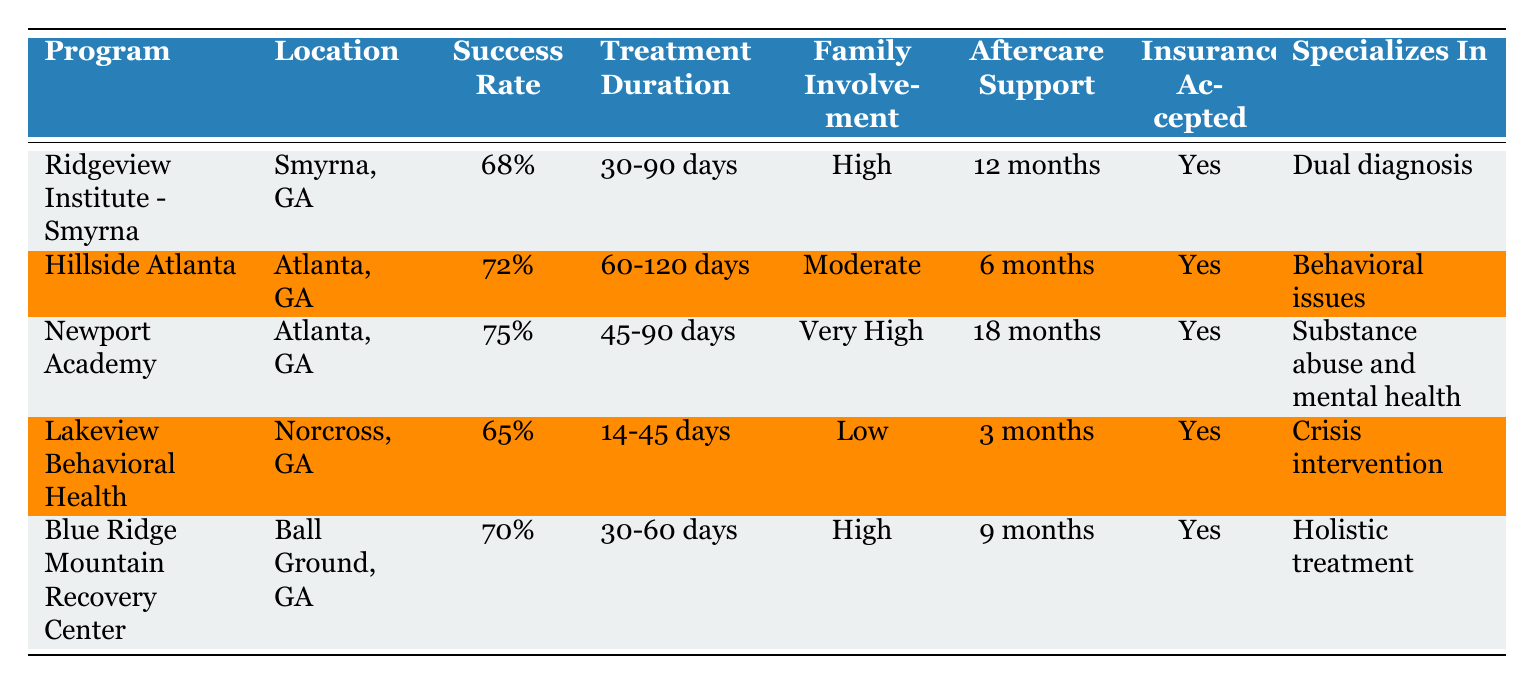What is the success rate of Newport Academy? The table lists Newport Academy's success rate in the third column of its respective row. It shows that Newport Academy has a success rate of 75%.
Answer: 75% Which program has the lowest success rate? By examining the "Success Rate" column for each program, we can see that Lakeview Behavioral Health has the lowest success rate at 65%.
Answer: Lakeview Behavioral Health What is the average success rate of the programs listed? The success rates of the programs are 68%, 72%, 75%, 65%, and 70%. To find the average, we first sum these rates: 68 + 72 + 75 + 65 + 70 = 350. Then we divide by the number of programs (5): 350 / 5 = 70%.
Answer: 70% Does Hillside Atlanta provide aftercare support for more than 6 months? Checking the "Aftercare Support" column for Hillside Atlanta, we find that it provides 6 months of aftercare support, which means it does not exceed 6 months.
Answer: No Which program has the longest aftercare support duration? Reviewing the "Aftercare Support" column, Newport Academy offers 18 months of aftercare support, which is the highest compared to the other programs.
Answer: Newport Academy 